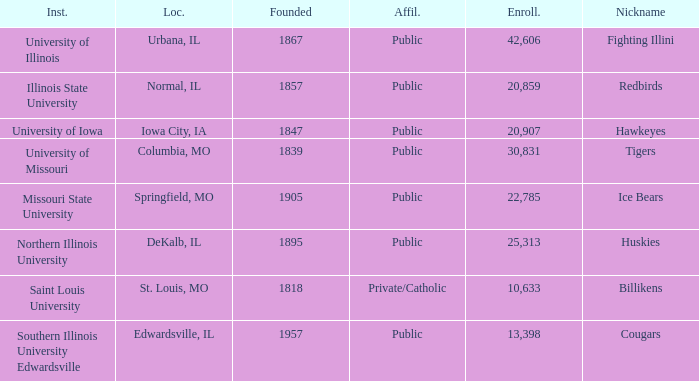What is Southern Illinois University Edwardsville's affiliation? Public. 